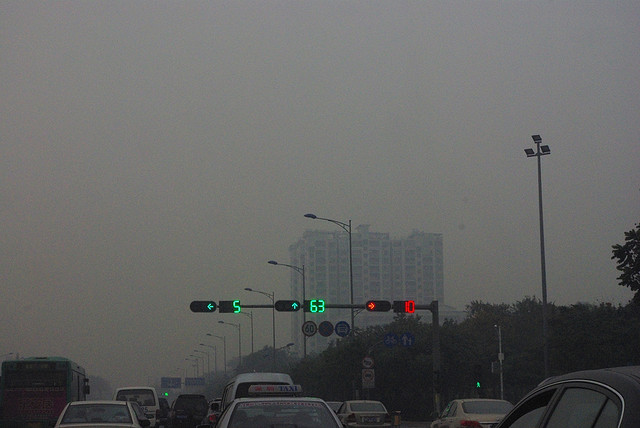<image>How is the traffic light? It is ambiguous to specify the state of the traffic light. It can be on green, red or both. What do the traffic lights say? I am not sure what the traffic lights say. It could be '5 63 10', '5 and 63', 'stop and go', '5 63 yellow red' or 'go'. How many Volkswagens are visible? I am not sure how many Volkswagens are visible. It can be 0, 1, 2, or 8. What vehicle is visible? It is ambiguous to determine the exact vehicle. It could be a car, a bus or a taxi. How is the traffic light? I don't know how the traffic light is. It can be either green or red. What do the traffic lights say? I don't know what the traffic lights say. It can be seen '5 63 10', 'numbers', '5 and 63', or '63'. What vehicle is visible? I am not sure what vehicle is visible. It can be several, taxi, car, cars, bus, or multiple vehicles. How many Volkswagens are visible? I am not sure how many Volkswagens are visible. It can be seen 0, 1, 2 or 8 Volkswagens. 